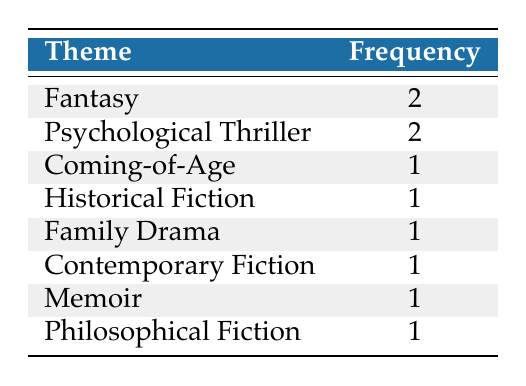What is the most common theme among the bestselling novels? The table shows that the themes "Fantasy" and "Psychological Thriller" both have a frequency of 2, which is higher than any other theme. Therefore, these two are the most common themes.
Answer: Fantasy and Psychological Thriller How many themes in total are represented in the table? By counting the number of unique themes listed in the table, we see there are eight different themes: Fantasy, Psychological Thriller, Coming-of-Age, Historical Fiction, Family Drama, Contemporary Fiction, Memoir, and Philosophical Fiction.
Answer: 8 Is there a theme that has only one novel associated with it? Looking at the frequency distribution, the themes "Coming-of-Age," "Historical Fiction," "Family Drama," "Contemporary Fiction," "Memoir," and "Philosophical Fiction" each have a frequency of 1, indicating that one novel is associated with each of these themes.
Answer: Yes What is the total frequency of the themes categorized under Fiction (including sub-genres)? The themes that fall under Fiction include Fantasy, Psychological Thriller, Coming-of-Age, Historical Fiction, Family Drama, Contemporary Fiction, and Philosophical Fiction. Adding their frequencies gives 2 (Fantasy) + 2 (Psychological Thriller) + 1 (Coming-of-Age) + 1 (Historical Fiction) + 1 (Family Drama) + 1 (Contemporary Fiction) + 1 (Philosophical Fiction) = 9.
Answer: 9 How many themes have a higher frequency than 1? The themes that have a frequency greater than 1 are "Fantasy" and "Psychological Thriller," which means there are two themes with a frequency higher than 1.
Answer: 2 Which theme is the least represented in the bestselling novels? The themes with the least representation, having a frequency of 1 each, include "Coming-of-Age," "Historical Fiction," "Family Drama," "Contemporary Fiction," "Memoir," and "Philosophical Fiction." Therefore, there are multiple least represented themes.
Answer: Multiple themes (6 themes with 1 each) 